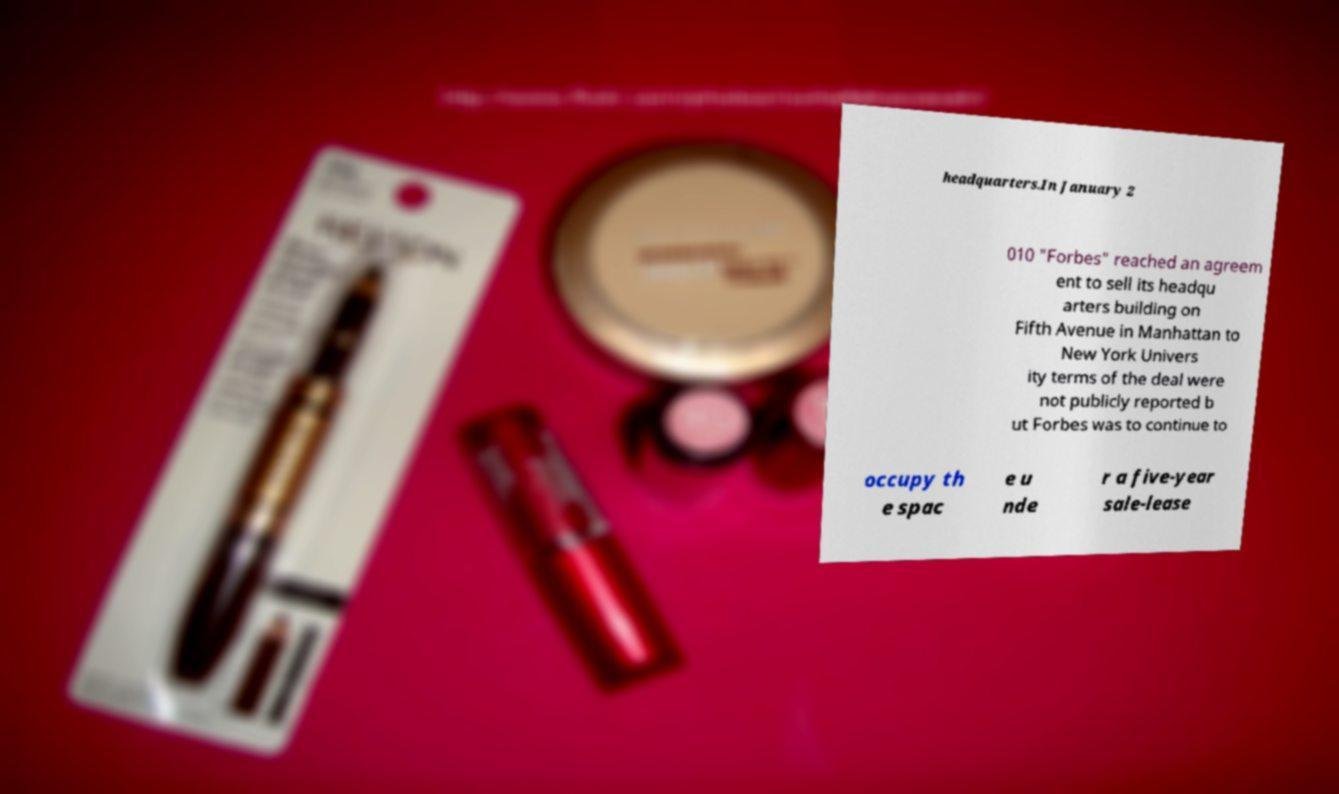What messages or text are displayed in this image? I need them in a readable, typed format. headquarters.In January 2 010 "Forbes" reached an agreem ent to sell its headqu arters building on Fifth Avenue in Manhattan to New York Univers ity terms of the deal were not publicly reported b ut Forbes was to continue to occupy th e spac e u nde r a five-year sale-lease 